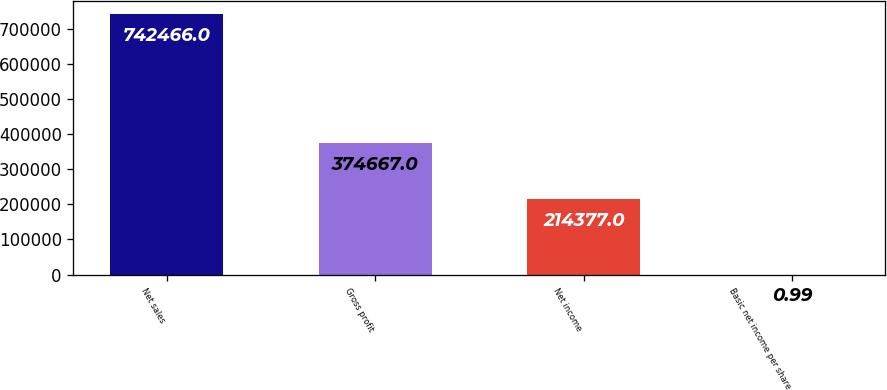<chart> <loc_0><loc_0><loc_500><loc_500><bar_chart><fcel>Net sales<fcel>Gross profit<fcel>Net income<fcel>Basic net income per share<nl><fcel>742466<fcel>374667<fcel>214377<fcel>0.99<nl></chart> 